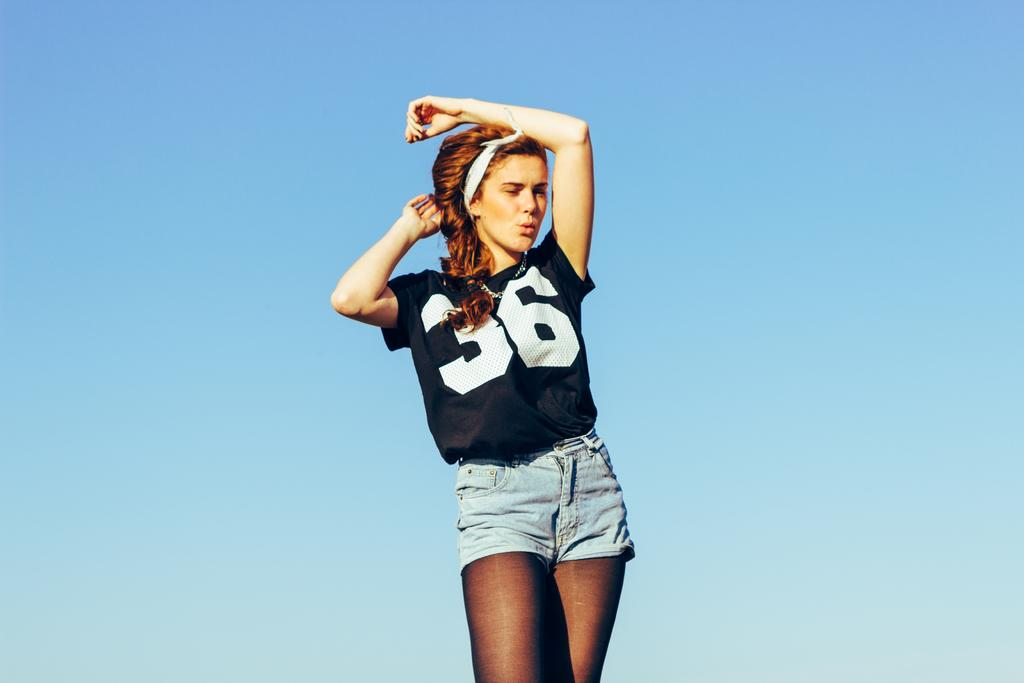What can be seen in the background of the image? The sky is visible in the background of the image. Who is present in the image? There is a woman in the image. What is the woman wearing? The woman is wearing a black t-shirt and denim shorts. What is the woman doing in the image? The woman is standing and giving a pose. What type of fruit is the woman holding in the image? There is no fruit present in the image; the woman is not holding any fruit. 